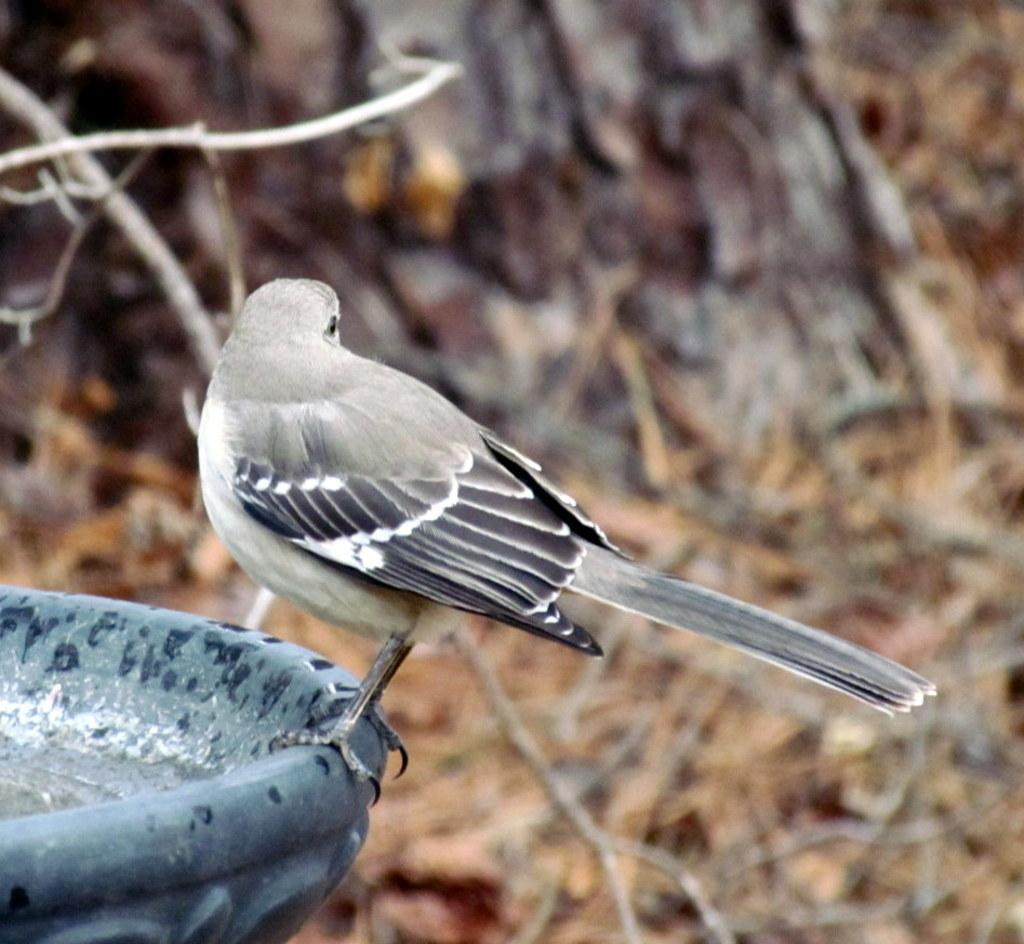What type of animal is in the image? There is a bird in the image. Where is the bird located? The bird is on a water fountain. Can you describe the bird's coloring? The bird has grey and black coloring. What other natural element is visible in the image? There is a tree visible in the image. What type of cherry is being reported on the news in the image? There is no cherry or news report present in the image; it features a bird on a water fountain and a tree. Can you tell me how far the ocean is from the bird in the image? There is no ocean visible in the image, so it is not possible to determine its distance from the bird. 